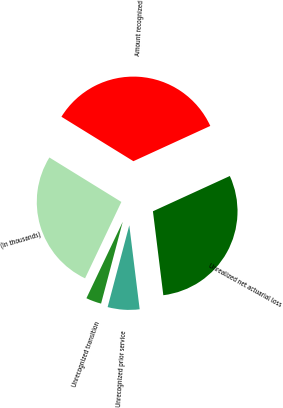<chart> <loc_0><loc_0><loc_500><loc_500><pie_chart><fcel>(In thousands)<fcel>Unrecognized transition<fcel>Unrecognized prior service<fcel>Unrealized net actuarial loss<fcel>Amount recognized<nl><fcel>26.74%<fcel>2.94%<fcel>6.08%<fcel>29.88%<fcel>34.35%<nl></chart> 